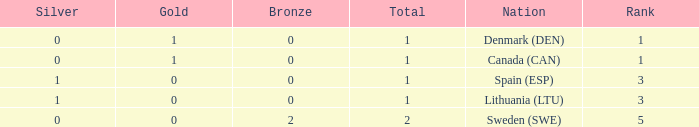What is the rank when there was less than 1 gold, 0 bronze, and more than 1 total? None. 